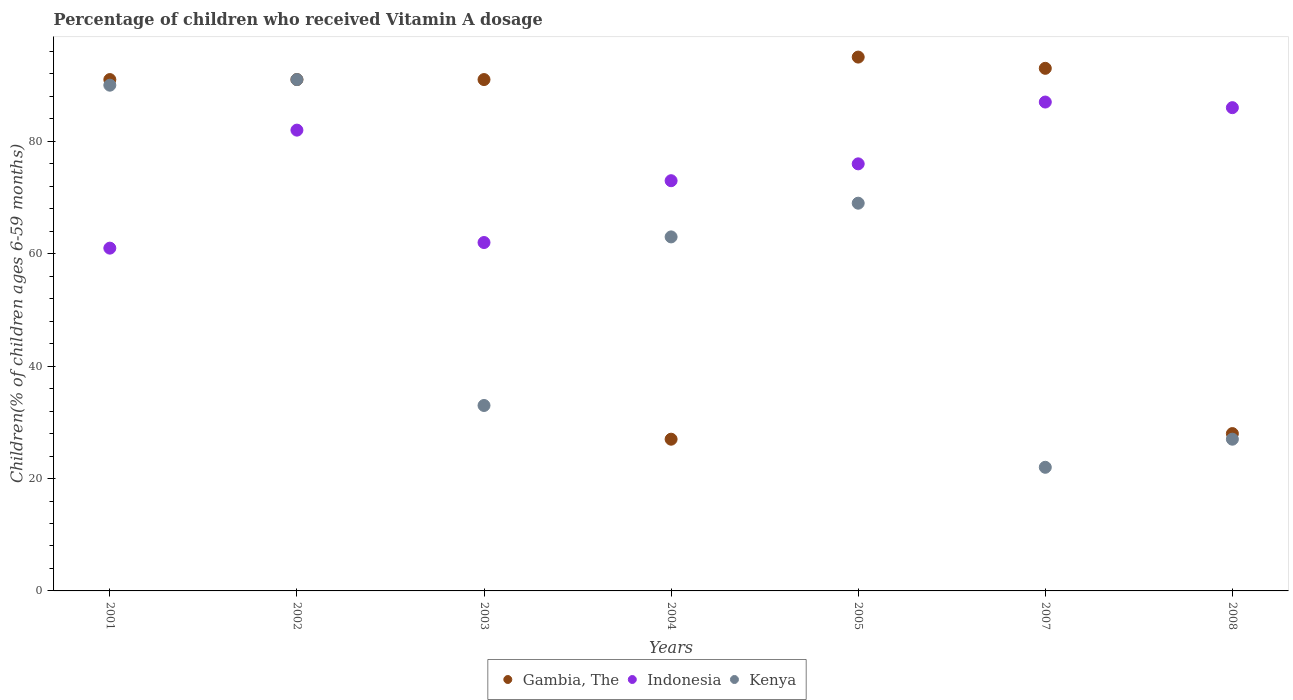Is the number of dotlines equal to the number of legend labels?
Give a very brief answer. Yes. What is the percentage of children who received Vitamin A dosage in Gambia, The in 2005?
Provide a short and direct response. 95. Across all years, what is the maximum percentage of children who received Vitamin A dosage in Kenya?
Make the answer very short. 91. In which year was the percentage of children who received Vitamin A dosage in Kenya minimum?
Your answer should be compact. 2007. What is the total percentage of children who received Vitamin A dosage in Gambia, The in the graph?
Provide a succinct answer. 516. What is the difference between the percentage of children who received Vitamin A dosage in Kenya in 2004 and that in 2007?
Make the answer very short. 41. What is the average percentage of children who received Vitamin A dosage in Indonesia per year?
Your response must be concise. 75.29. In how many years, is the percentage of children who received Vitamin A dosage in Kenya greater than 20 %?
Keep it short and to the point. 7. What is the ratio of the percentage of children who received Vitamin A dosage in Kenya in 2002 to that in 2004?
Provide a succinct answer. 1.44. Is the percentage of children who received Vitamin A dosage in Gambia, The in 2002 less than that in 2008?
Ensure brevity in your answer.  No. What is the difference between the highest and the second highest percentage of children who received Vitamin A dosage in Kenya?
Offer a terse response. 1. Is the sum of the percentage of children who received Vitamin A dosage in Gambia, The in 2002 and 2003 greater than the maximum percentage of children who received Vitamin A dosage in Indonesia across all years?
Give a very brief answer. Yes. Is it the case that in every year, the sum of the percentage of children who received Vitamin A dosage in Indonesia and percentage of children who received Vitamin A dosage in Gambia, The  is greater than the percentage of children who received Vitamin A dosage in Kenya?
Offer a very short reply. Yes. Does the percentage of children who received Vitamin A dosage in Kenya monotonically increase over the years?
Provide a short and direct response. No. Is the percentage of children who received Vitamin A dosage in Indonesia strictly greater than the percentage of children who received Vitamin A dosage in Gambia, The over the years?
Your response must be concise. No. Is the percentage of children who received Vitamin A dosage in Gambia, The strictly less than the percentage of children who received Vitamin A dosage in Kenya over the years?
Provide a succinct answer. No. How many dotlines are there?
Your answer should be very brief. 3. What is the difference between two consecutive major ticks on the Y-axis?
Offer a terse response. 20. Are the values on the major ticks of Y-axis written in scientific E-notation?
Make the answer very short. No. Does the graph contain any zero values?
Ensure brevity in your answer.  No. Does the graph contain grids?
Make the answer very short. No. Where does the legend appear in the graph?
Give a very brief answer. Bottom center. How are the legend labels stacked?
Keep it short and to the point. Horizontal. What is the title of the graph?
Keep it short and to the point. Percentage of children who received Vitamin A dosage. What is the label or title of the X-axis?
Your response must be concise. Years. What is the label or title of the Y-axis?
Offer a terse response. Children(% of children ages 6-59 months). What is the Children(% of children ages 6-59 months) of Gambia, The in 2001?
Offer a terse response. 91. What is the Children(% of children ages 6-59 months) in Kenya in 2001?
Provide a short and direct response. 90. What is the Children(% of children ages 6-59 months) in Gambia, The in 2002?
Offer a very short reply. 91. What is the Children(% of children ages 6-59 months) in Indonesia in 2002?
Your answer should be very brief. 82. What is the Children(% of children ages 6-59 months) of Kenya in 2002?
Keep it short and to the point. 91. What is the Children(% of children ages 6-59 months) of Gambia, The in 2003?
Your response must be concise. 91. What is the Children(% of children ages 6-59 months) of Indonesia in 2003?
Give a very brief answer. 62. What is the Children(% of children ages 6-59 months) in Kenya in 2004?
Offer a terse response. 63. What is the Children(% of children ages 6-59 months) of Kenya in 2005?
Make the answer very short. 69. What is the Children(% of children ages 6-59 months) of Gambia, The in 2007?
Your answer should be very brief. 93. What is the Children(% of children ages 6-59 months) of Indonesia in 2007?
Make the answer very short. 87. Across all years, what is the maximum Children(% of children ages 6-59 months) of Kenya?
Your answer should be very brief. 91. Across all years, what is the minimum Children(% of children ages 6-59 months) in Gambia, The?
Offer a terse response. 27. Across all years, what is the minimum Children(% of children ages 6-59 months) in Indonesia?
Your response must be concise. 61. What is the total Children(% of children ages 6-59 months) in Gambia, The in the graph?
Ensure brevity in your answer.  516. What is the total Children(% of children ages 6-59 months) in Indonesia in the graph?
Make the answer very short. 527. What is the total Children(% of children ages 6-59 months) of Kenya in the graph?
Keep it short and to the point. 395. What is the difference between the Children(% of children ages 6-59 months) in Gambia, The in 2001 and that in 2002?
Your answer should be compact. 0. What is the difference between the Children(% of children ages 6-59 months) in Indonesia in 2001 and that in 2002?
Provide a short and direct response. -21. What is the difference between the Children(% of children ages 6-59 months) of Indonesia in 2001 and that in 2003?
Ensure brevity in your answer.  -1. What is the difference between the Children(% of children ages 6-59 months) of Kenya in 2001 and that in 2003?
Make the answer very short. 57. What is the difference between the Children(% of children ages 6-59 months) in Gambia, The in 2001 and that in 2004?
Your answer should be very brief. 64. What is the difference between the Children(% of children ages 6-59 months) in Kenya in 2001 and that in 2004?
Provide a short and direct response. 27. What is the difference between the Children(% of children ages 6-59 months) of Kenya in 2001 and that in 2005?
Provide a short and direct response. 21. What is the difference between the Children(% of children ages 6-59 months) of Gambia, The in 2001 and that in 2007?
Provide a short and direct response. -2. What is the difference between the Children(% of children ages 6-59 months) in Kenya in 2001 and that in 2007?
Offer a terse response. 68. What is the difference between the Children(% of children ages 6-59 months) in Gambia, The in 2001 and that in 2008?
Your answer should be compact. 63. What is the difference between the Children(% of children ages 6-59 months) of Indonesia in 2002 and that in 2003?
Your response must be concise. 20. What is the difference between the Children(% of children ages 6-59 months) in Kenya in 2002 and that in 2003?
Your response must be concise. 58. What is the difference between the Children(% of children ages 6-59 months) in Gambia, The in 2002 and that in 2005?
Your answer should be compact. -4. What is the difference between the Children(% of children ages 6-59 months) of Indonesia in 2002 and that in 2005?
Your response must be concise. 6. What is the difference between the Children(% of children ages 6-59 months) in Indonesia in 2002 and that in 2007?
Offer a very short reply. -5. What is the difference between the Children(% of children ages 6-59 months) in Gambia, The in 2002 and that in 2008?
Provide a succinct answer. 63. What is the difference between the Children(% of children ages 6-59 months) in Gambia, The in 2003 and that in 2004?
Offer a very short reply. 64. What is the difference between the Children(% of children ages 6-59 months) in Indonesia in 2003 and that in 2004?
Your answer should be very brief. -11. What is the difference between the Children(% of children ages 6-59 months) of Gambia, The in 2003 and that in 2005?
Ensure brevity in your answer.  -4. What is the difference between the Children(% of children ages 6-59 months) in Kenya in 2003 and that in 2005?
Offer a terse response. -36. What is the difference between the Children(% of children ages 6-59 months) in Gambia, The in 2003 and that in 2008?
Keep it short and to the point. 63. What is the difference between the Children(% of children ages 6-59 months) of Indonesia in 2003 and that in 2008?
Ensure brevity in your answer.  -24. What is the difference between the Children(% of children ages 6-59 months) in Kenya in 2003 and that in 2008?
Your answer should be compact. 6. What is the difference between the Children(% of children ages 6-59 months) in Gambia, The in 2004 and that in 2005?
Your answer should be compact. -68. What is the difference between the Children(% of children ages 6-59 months) of Indonesia in 2004 and that in 2005?
Provide a succinct answer. -3. What is the difference between the Children(% of children ages 6-59 months) in Gambia, The in 2004 and that in 2007?
Offer a terse response. -66. What is the difference between the Children(% of children ages 6-59 months) of Indonesia in 2004 and that in 2007?
Offer a very short reply. -14. What is the difference between the Children(% of children ages 6-59 months) in Kenya in 2004 and that in 2007?
Your response must be concise. 41. What is the difference between the Children(% of children ages 6-59 months) in Gambia, The in 2005 and that in 2007?
Your answer should be compact. 2. What is the difference between the Children(% of children ages 6-59 months) in Indonesia in 2005 and that in 2007?
Ensure brevity in your answer.  -11. What is the difference between the Children(% of children ages 6-59 months) in Kenya in 2005 and that in 2007?
Your answer should be compact. 47. What is the difference between the Children(% of children ages 6-59 months) of Gambia, The in 2005 and that in 2008?
Your response must be concise. 67. What is the difference between the Children(% of children ages 6-59 months) of Indonesia in 2005 and that in 2008?
Offer a very short reply. -10. What is the difference between the Children(% of children ages 6-59 months) of Kenya in 2005 and that in 2008?
Ensure brevity in your answer.  42. What is the difference between the Children(% of children ages 6-59 months) in Kenya in 2007 and that in 2008?
Offer a very short reply. -5. What is the difference between the Children(% of children ages 6-59 months) in Gambia, The in 2001 and the Children(% of children ages 6-59 months) in Indonesia in 2002?
Provide a short and direct response. 9. What is the difference between the Children(% of children ages 6-59 months) in Gambia, The in 2001 and the Children(% of children ages 6-59 months) in Kenya in 2002?
Make the answer very short. 0. What is the difference between the Children(% of children ages 6-59 months) of Indonesia in 2001 and the Children(% of children ages 6-59 months) of Kenya in 2002?
Make the answer very short. -30. What is the difference between the Children(% of children ages 6-59 months) of Gambia, The in 2001 and the Children(% of children ages 6-59 months) of Kenya in 2003?
Make the answer very short. 58. What is the difference between the Children(% of children ages 6-59 months) in Gambia, The in 2001 and the Children(% of children ages 6-59 months) in Indonesia in 2004?
Your answer should be compact. 18. What is the difference between the Children(% of children ages 6-59 months) in Gambia, The in 2001 and the Children(% of children ages 6-59 months) in Kenya in 2004?
Make the answer very short. 28. What is the difference between the Children(% of children ages 6-59 months) of Indonesia in 2001 and the Children(% of children ages 6-59 months) of Kenya in 2004?
Give a very brief answer. -2. What is the difference between the Children(% of children ages 6-59 months) in Gambia, The in 2001 and the Children(% of children ages 6-59 months) in Kenya in 2007?
Provide a succinct answer. 69. What is the difference between the Children(% of children ages 6-59 months) in Gambia, The in 2001 and the Children(% of children ages 6-59 months) in Indonesia in 2008?
Offer a terse response. 5. What is the difference between the Children(% of children ages 6-59 months) in Gambia, The in 2002 and the Children(% of children ages 6-59 months) in Kenya in 2003?
Provide a short and direct response. 58. What is the difference between the Children(% of children ages 6-59 months) of Gambia, The in 2002 and the Children(% of children ages 6-59 months) of Kenya in 2004?
Offer a terse response. 28. What is the difference between the Children(% of children ages 6-59 months) in Indonesia in 2002 and the Children(% of children ages 6-59 months) in Kenya in 2004?
Your answer should be very brief. 19. What is the difference between the Children(% of children ages 6-59 months) in Gambia, The in 2002 and the Children(% of children ages 6-59 months) in Kenya in 2005?
Offer a terse response. 22. What is the difference between the Children(% of children ages 6-59 months) in Gambia, The in 2002 and the Children(% of children ages 6-59 months) in Indonesia in 2007?
Ensure brevity in your answer.  4. What is the difference between the Children(% of children ages 6-59 months) of Gambia, The in 2002 and the Children(% of children ages 6-59 months) of Kenya in 2007?
Offer a very short reply. 69. What is the difference between the Children(% of children ages 6-59 months) of Indonesia in 2002 and the Children(% of children ages 6-59 months) of Kenya in 2008?
Provide a succinct answer. 55. What is the difference between the Children(% of children ages 6-59 months) in Indonesia in 2003 and the Children(% of children ages 6-59 months) in Kenya in 2004?
Your answer should be very brief. -1. What is the difference between the Children(% of children ages 6-59 months) in Gambia, The in 2003 and the Children(% of children ages 6-59 months) in Indonesia in 2005?
Provide a succinct answer. 15. What is the difference between the Children(% of children ages 6-59 months) of Gambia, The in 2003 and the Children(% of children ages 6-59 months) of Kenya in 2005?
Make the answer very short. 22. What is the difference between the Children(% of children ages 6-59 months) in Gambia, The in 2003 and the Children(% of children ages 6-59 months) in Indonesia in 2007?
Keep it short and to the point. 4. What is the difference between the Children(% of children ages 6-59 months) in Indonesia in 2003 and the Children(% of children ages 6-59 months) in Kenya in 2007?
Ensure brevity in your answer.  40. What is the difference between the Children(% of children ages 6-59 months) of Gambia, The in 2003 and the Children(% of children ages 6-59 months) of Indonesia in 2008?
Offer a terse response. 5. What is the difference between the Children(% of children ages 6-59 months) of Gambia, The in 2003 and the Children(% of children ages 6-59 months) of Kenya in 2008?
Your answer should be very brief. 64. What is the difference between the Children(% of children ages 6-59 months) of Gambia, The in 2004 and the Children(% of children ages 6-59 months) of Indonesia in 2005?
Your answer should be compact. -49. What is the difference between the Children(% of children ages 6-59 months) of Gambia, The in 2004 and the Children(% of children ages 6-59 months) of Kenya in 2005?
Provide a succinct answer. -42. What is the difference between the Children(% of children ages 6-59 months) of Indonesia in 2004 and the Children(% of children ages 6-59 months) of Kenya in 2005?
Make the answer very short. 4. What is the difference between the Children(% of children ages 6-59 months) in Gambia, The in 2004 and the Children(% of children ages 6-59 months) in Indonesia in 2007?
Your response must be concise. -60. What is the difference between the Children(% of children ages 6-59 months) of Gambia, The in 2004 and the Children(% of children ages 6-59 months) of Kenya in 2007?
Offer a very short reply. 5. What is the difference between the Children(% of children ages 6-59 months) of Indonesia in 2004 and the Children(% of children ages 6-59 months) of Kenya in 2007?
Your answer should be very brief. 51. What is the difference between the Children(% of children ages 6-59 months) in Gambia, The in 2004 and the Children(% of children ages 6-59 months) in Indonesia in 2008?
Your response must be concise. -59. What is the difference between the Children(% of children ages 6-59 months) in Gambia, The in 2004 and the Children(% of children ages 6-59 months) in Kenya in 2008?
Offer a very short reply. 0. What is the difference between the Children(% of children ages 6-59 months) of Gambia, The in 2005 and the Children(% of children ages 6-59 months) of Kenya in 2008?
Offer a very short reply. 68. What is the difference between the Children(% of children ages 6-59 months) of Gambia, The in 2007 and the Children(% of children ages 6-59 months) of Indonesia in 2008?
Offer a terse response. 7. What is the average Children(% of children ages 6-59 months) of Gambia, The per year?
Provide a succinct answer. 73.71. What is the average Children(% of children ages 6-59 months) of Indonesia per year?
Keep it short and to the point. 75.29. What is the average Children(% of children ages 6-59 months) in Kenya per year?
Your answer should be very brief. 56.43. In the year 2002, what is the difference between the Children(% of children ages 6-59 months) of Indonesia and Children(% of children ages 6-59 months) of Kenya?
Make the answer very short. -9. In the year 2003, what is the difference between the Children(% of children ages 6-59 months) in Gambia, The and Children(% of children ages 6-59 months) in Indonesia?
Provide a succinct answer. 29. In the year 2003, what is the difference between the Children(% of children ages 6-59 months) in Indonesia and Children(% of children ages 6-59 months) in Kenya?
Ensure brevity in your answer.  29. In the year 2004, what is the difference between the Children(% of children ages 6-59 months) of Gambia, The and Children(% of children ages 6-59 months) of Indonesia?
Offer a terse response. -46. In the year 2004, what is the difference between the Children(% of children ages 6-59 months) of Gambia, The and Children(% of children ages 6-59 months) of Kenya?
Your answer should be very brief. -36. In the year 2005, what is the difference between the Children(% of children ages 6-59 months) of Gambia, The and Children(% of children ages 6-59 months) of Indonesia?
Your response must be concise. 19. In the year 2005, what is the difference between the Children(% of children ages 6-59 months) in Gambia, The and Children(% of children ages 6-59 months) in Kenya?
Provide a succinct answer. 26. In the year 2005, what is the difference between the Children(% of children ages 6-59 months) in Indonesia and Children(% of children ages 6-59 months) in Kenya?
Offer a very short reply. 7. In the year 2007, what is the difference between the Children(% of children ages 6-59 months) of Gambia, The and Children(% of children ages 6-59 months) of Kenya?
Offer a terse response. 71. In the year 2008, what is the difference between the Children(% of children ages 6-59 months) in Gambia, The and Children(% of children ages 6-59 months) in Indonesia?
Make the answer very short. -58. In the year 2008, what is the difference between the Children(% of children ages 6-59 months) of Gambia, The and Children(% of children ages 6-59 months) of Kenya?
Your answer should be very brief. 1. What is the ratio of the Children(% of children ages 6-59 months) of Indonesia in 2001 to that in 2002?
Ensure brevity in your answer.  0.74. What is the ratio of the Children(% of children ages 6-59 months) in Gambia, The in 2001 to that in 2003?
Provide a short and direct response. 1. What is the ratio of the Children(% of children ages 6-59 months) of Indonesia in 2001 to that in 2003?
Your answer should be very brief. 0.98. What is the ratio of the Children(% of children ages 6-59 months) in Kenya in 2001 to that in 2003?
Provide a short and direct response. 2.73. What is the ratio of the Children(% of children ages 6-59 months) in Gambia, The in 2001 to that in 2004?
Make the answer very short. 3.37. What is the ratio of the Children(% of children ages 6-59 months) in Indonesia in 2001 to that in 2004?
Provide a short and direct response. 0.84. What is the ratio of the Children(% of children ages 6-59 months) in Kenya in 2001 to that in 2004?
Ensure brevity in your answer.  1.43. What is the ratio of the Children(% of children ages 6-59 months) in Gambia, The in 2001 to that in 2005?
Your answer should be compact. 0.96. What is the ratio of the Children(% of children ages 6-59 months) in Indonesia in 2001 to that in 2005?
Provide a succinct answer. 0.8. What is the ratio of the Children(% of children ages 6-59 months) of Kenya in 2001 to that in 2005?
Your answer should be compact. 1.3. What is the ratio of the Children(% of children ages 6-59 months) in Gambia, The in 2001 to that in 2007?
Your answer should be compact. 0.98. What is the ratio of the Children(% of children ages 6-59 months) in Indonesia in 2001 to that in 2007?
Provide a short and direct response. 0.7. What is the ratio of the Children(% of children ages 6-59 months) in Kenya in 2001 to that in 2007?
Your answer should be very brief. 4.09. What is the ratio of the Children(% of children ages 6-59 months) of Indonesia in 2001 to that in 2008?
Your answer should be compact. 0.71. What is the ratio of the Children(% of children ages 6-59 months) of Kenya in 2001 to that in 2008?
Provide a short and direct response. 3.33. What is the ratio of the Children(% of children ages 6-59 months) of Gambia, The in 2002 to that in 2003?
Offer a very short reply. 1. What is the ratio of the Children(% of children ages 6-59 months) in Indonesia in 2002 to that in 2003?
Your response must be concise. 1.32. What is the ratio of the Children(% of children ages 6-59 months) of Kenya in 2002 to that in 2003?
Your response must be concise. 2.76. What is the ratio of the Children(% of children ages 6-59 months) in Gambia, The in 2002 to that in 2004?
Your answer should be compact. 3.37. What is the ratio of the Children(% of children ages 6-59 months) in Indonesia in 2002 to that in 2004?
Your answer should be very brief. 1.12. What is the ratio of the Children(% of children ages 6-59 months) of Kenya in 2002 to that in 2004?
Keep it short and to the point. 1.44. What is the ratio of the Children(% of children ages 6-59 months) of Gambia, The in 2002 to that in 2005?
Offer a very short reply. 0.96. What is the ratio of the Children(% of children ages 6-59 months) in Indonesia in 2002 to that in 2005?
Keep it short and to the point. 1.08. What is the ratio of the Children(% of children ages 6-59 months) in Kenya in 2002 to that in 2005?
Make the answer very short. 1.32. What is the ratio of the Children(% of children ages 6-59 months) of Gambia, The in 2002 to that in 2007?
Give a very brief answer. 0.98. What is the ratio of the Children(% of children ages 6-59 months) in Indonesia in 2002 to that in 2007?
Give a very brief answer. 0.94. What is the ratio of the Children(% of children ages 6-59 months) of Kenya in 2002 to that in 2007?
Ensure brevity in your answer.  4.14. What is the ratio of the Children(% of children ages 6-59 months) in Gambia, The in 2002 to that in 2008?
Make the answer very short. 3.25. What is the ratio of the Children(% of children ages 6-59 months) of Indonesia in 2002 to that in 2008?
Make the answer very short. 0.95. What is the ratio of the Children(% of children ages 6-59 months) in Kenya in 2002 to that in 2008?
Make the answer very short. 3.37. What is the ratio of the Children(% of children ages 6-59 months) in Gambia, The in 2003 to that in 2004?
Make the answer very short. 3.37. What is the ratio of the Children(% of children ages 6-59 months) of Indonesia in 2003 to that in 2004?
Your response must be concise. 0.85. What is the ratio of the Children(% of children ages 6-59 months) of Kenya in 2003 to that in 2004?
Your answer should be compact. 0.52. What is the ratio of the Children(% of children ages 6-59 months) in Gambia, The in 2003 to that in 2005?
Provide a short and direct response. 0.96. What is the ratio of the Children(% of children ages 6-59 months) in Indonesia in 2003 to that in 2005?
Ensure brevity in your answer.  0.82. What is the ratio of the Children(% of children ages 6-59 months) in Kenya in 2003 to that in 2005?
Your answer should be very brief. 0.48. What is the ratio of the Children(% of children ages 6-59 months) in Gambia, The in 2003 to that in 2007?
Provide a short and direct response. 0.98. What is the ratio of the Children(% of children ages 6-59 months) in Indonesia in 2003 to that in 2007?
Provide a short and direct response. 0.71. What is the ratio of the Children(% of children ages 6-59 months) of Kenya in 2003 to that in 2007?
Your response must be concise. 1.5. What is the ratio of the Children(% of children ages 6-59 months) of Gambia, The in 2003 to that in 2008?
Offer a terse response. 3.25. What is the ratio of the Children(% of children ages 6-59 months) of Indonesia in 2003 to that in 2008?
Your answer should be compact. 0.72. What is the ratio of the Children(% of children ages 6-59 months) of Kenya in 2003 to that in 2008?
Offer a very short reply. 1.22. What is the ratio of the Children(% of children ages 6-59 months) in Gambia, The in 2004 to that in 2005?
Ensure brevity in your answer.  0.28. What is the ratio of the Children(% of children ages 6-59 months) in Indonesia in 2004 to that in 2005?
Offer a very short reply. 0.96. What is the ratio of the Children(% of children ages 6-59 months) of Kenya in 2004 to that in 2005?
Your answer should be compact. 0.91. What is the ratio of the Children(% of children ages 6-59 months) in Gambia, The in 2004 to that in 2007?
Keep it short and to the point. 0.29. What is the ratio of the Children(% of children ages 6-59 months) in Indonesia in 2004 to that in 2007?
Provide a succinct answer. 0.84. What is the ratio of the Children(% of children ages 6-59 months) in Kenya in 2004 to that in 2007?
Offer a terse response. 2.86. What is the ratio of the Children(% of children ages 6-59 months) in Indonesia in 2004 to that in 2008?
Your response must be concise. 0.85. What is the ratio of the Children(% of children ages 6-59 months) in Kenya in 2004 to that in 2008?
Offer a terse response. 2.33. What is the ratio of the Children(% of children ages 6-59 months) in Gambia, The in 2005 to that in 2007?
Keep it short and to the point. 1.02. What is the ratio of the Children(% of children ages 6-59 months) of Indonesia in 2005 to that in 2007?
Your answer should be very brief. 0.87. What is the ratio of the Children(% of children ages 6-59 months) of Kenya in 2005 to that in 2007?
Ensure brevity in your answer.  3.14. What is the ratio of the Children(% of children ages 6-59 months) in Gambia, The in 2005 to that in 2008?
Offer a very short reply. 3.39. What is the ratio of the Children(% of children ages 6-59 months) in Indonesia in 2005 to that in 2008?
Keep it short and to the point. 0.88. What is the ratio of the Children(% of children ages 6-59 months) in Kenya in 2005 to that in 2008?
Provide a succinct answer. 2.56. What is the ratio of the Children(% of children ages 6-59 months) in Gambia, The in 2007 to that in 2008?
Give a very brief answer. 3.32. What is the ratio of the Children(% of children ages 6-59 months) of Indonesia in 2007 to that in 2008?
Your response must be concise. 1.01. What is the ratio of the Children(% of children ages 6-59 months) of Kenya in 2007 to that in 2008?
Make the answer very short. 0.81. What is the difference between the highest and the second highest Children(% of children ages 6-59 months) of Gambia, The?
Your answer should be very brief. 2. What is the difference between the highest and the second highest Children(% of children ages 6-59 months) in Indonesia?
Keep it short and to the point. 1. What is the difference between the highest and the second highest Children(% of children ages 6-59 months) of Kenya?
Keep it short and to the point. 1. What is the difference between the highest and the lowest Children(% of children ages 6-59 months) in Gambia, The?
Your response must be concise. 68. What is the difference between the highest and the lowest Children(% of children ages 6-59 months) of Indonesia?
Offer a terse response. 26. What is the difference between the highest and the lowest Children(% of children ages 6-59 months) of Kenya?
Your answer should be very brief. 69. 